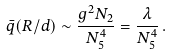<formula> <loc_0><loc_0><loc_500><loc_500>\bar { q } ( R / d ) \sim \frac { g ^ { 2 } N _ { 2 } } { N _ { 5 } ^ { 4 } } = \frac { \lambda } { N _ { 5 } ^ { 4 } } \, .</formula> 